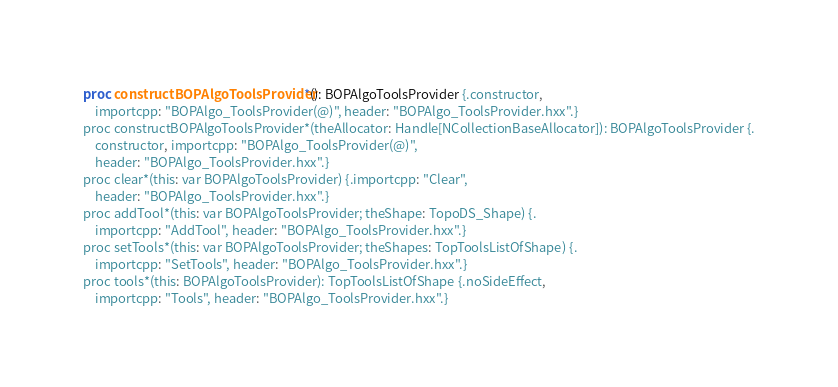Convert code to text. <code><loc_0><loc_0><loc_500><loc_500><_Nim_>

proc constructBOPAlgoToolsProvider*(): BOPAlgoToolsProvider {.constructor,
    importcpp: "BOPAlgo_ToolsProvider(@)", header: "BOPAlgo_ToolsProvider.hxx".}
proc constructBOPAlgoToolsProvider*(theAllocator: Handle[NCollectionBaseAllocator]): BOPAlgoToolsProvider {.
    constructor, importcpp: "BOPAlgo_ToolsProvider(@)",
    header: "BOPAlgo_ToolsProvider.hxx".}
proc clear*(this: var BOPAlgoToolsProvider) {.importcpp: "Clear",
    header: "BOPAlgo_ToolsProvider.hxx".}
proc addTool*(this: var BOPAlgoToolsProvider; theShape: TopoDS_Shape) {.
    importcpp: "AddTool", header: "BOPAlgo_ToolsProvider.hxx".}
proc setTools*(this: var BOPAlgoToolsProvider; theShapes: TopToolsListOfShape) {.
    importcpp: "SetTools", header: "BOPAlgo_ToolsProvider.hxx".}
proc tools*(this: BOPAlgoToolsProvider): TopToolsListOfShape {.noSideEffect,
    importcpp: "Tools", header: "BOPAlgo_ToolsProvider.hxx".}

























</code> 